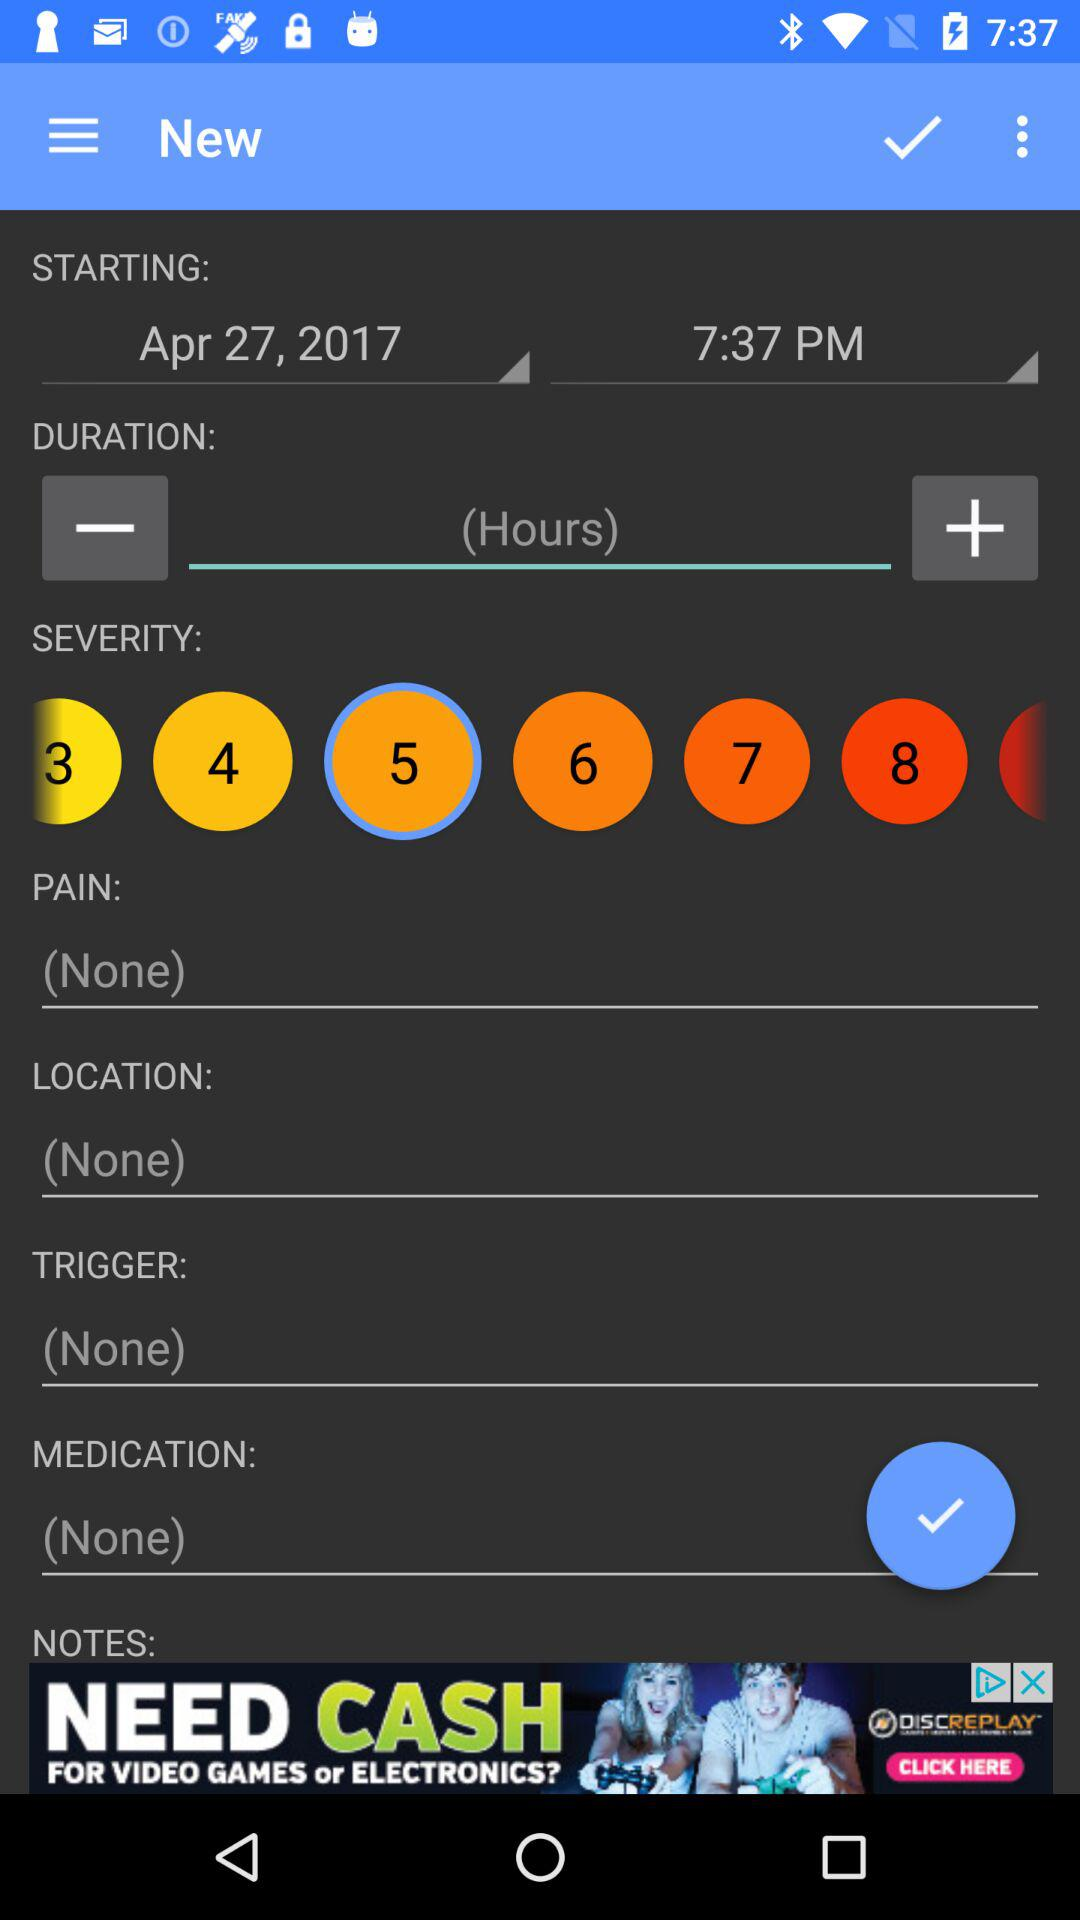What is the starting time for medication? The starting time for medication is 7:37 PM. 